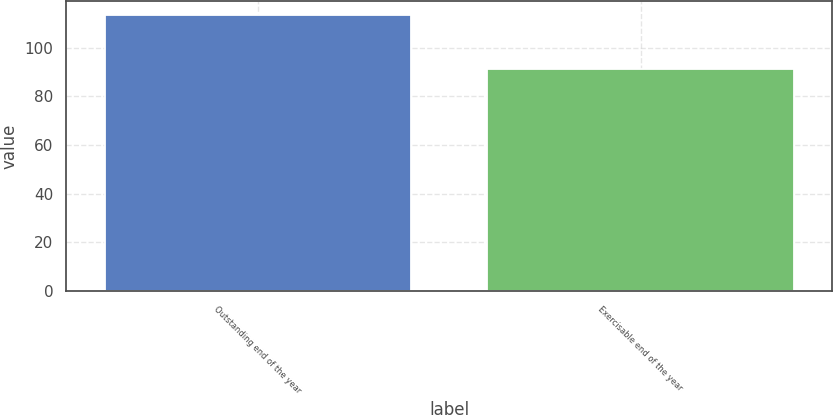<chart> <loc_0><loc_0><loc_500><loc_500><bar_chart><fcel>Outstanding end of the year<fcel>Exercisable end of the year<nl><fcel>113.49<fcel>91.21<nl></chart> 